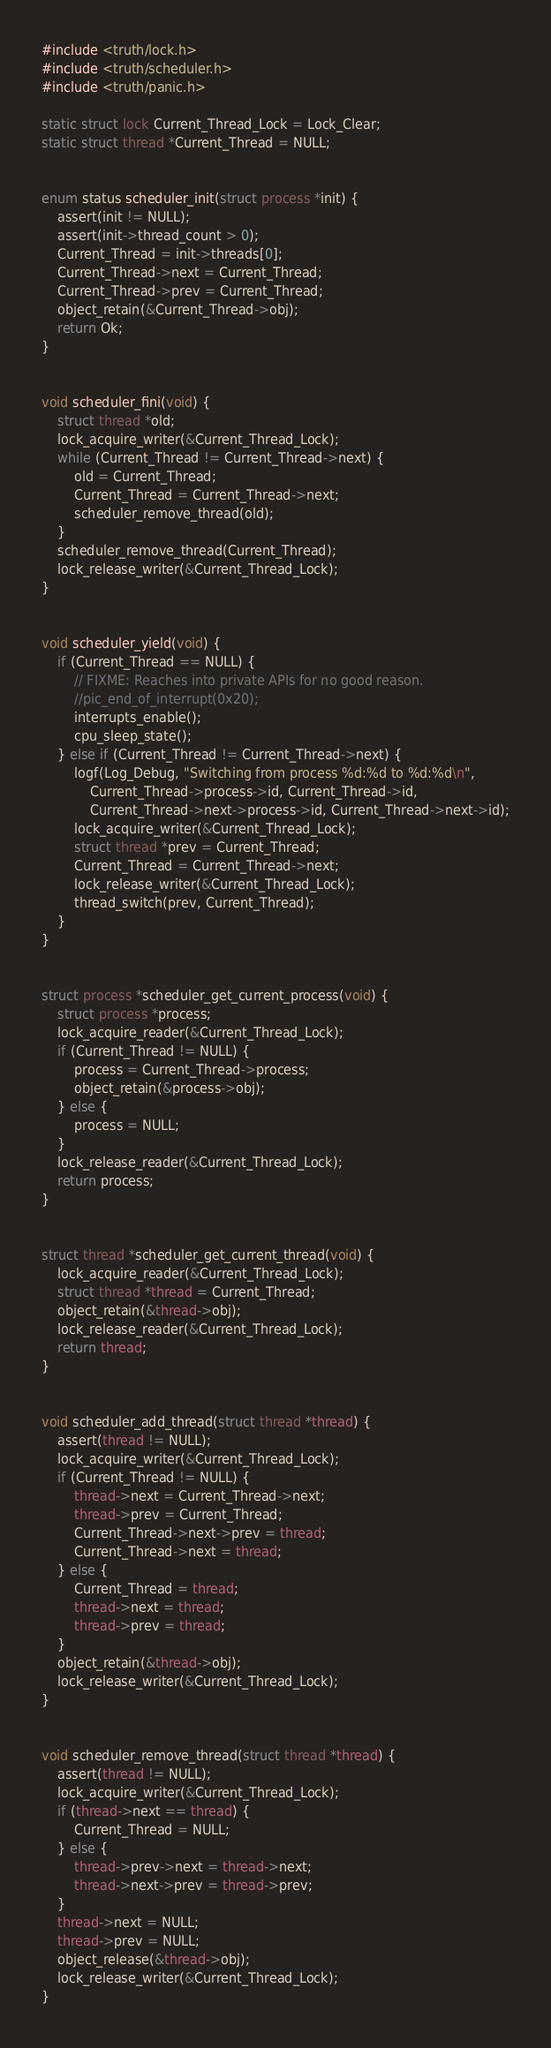Convert code to text. <code><loc_0><loc_0><loc_500><loc_500><_C_>#include <truth/lock.h>
#include <truth/scheduler.h>
#include <truth/panic.h>

static struct lock Current_Thread_Lock = Lock_Clear;
static struct thread *Current_Thread = NULL;


enum status scheduler_init(struct process *init) {
    assert(init != NULL);
    assert(init->thread_count > 0);
    Current_Thread = init->threads[0];
    Current_Thread->next = Current_Thread;
    Current_Thread->prev = Current_Thread;
    object_retain(&Current_Thread->obj);
    return Ok;
}


void scheduler_fini(void) {
    struct thread *old;
    lock_acquire_writer(&Current_Thread_Lock);
    while (Current_Thread != Current_Thread->next) {
        old = Current_Thread;
        Current_Thread = Current_Thread->next;
        scheduler_remove_thread(old);
    }
    scheduler_remove_thread(Current_Thread);
    lock_release_writer(&Current_Thread_Lock);
}


void scheduler_yield(void) {
    if (Current_Thread == NULL) {
        // FIXME: Reaches into private APIs for no good reason.
        //pic_end_of_interrupt(0x20);
        interrupts_enable();
        cpu_sleep_state();
    } else if (Current_Thread != Current_Thread->next) {
        logf(Log_Debug, "Switching from process %d:%d to %d:%d\n",
            Current_Thread->process->id, Current_Thread->id,
            Current_Thread->next->process->id, Current_Thread->next->id);
        lock_acquire_writer(&Current_Thread_Lock);
        struct thread *prev = Current_Thread;
        Current_Thread = Current_Thread->next;
        lock_release_writer(&Current_Thread_Lock);
        thread_switch(prev, Current_Thread);
    }
}


struct process *scheduler_get_current_process(void) {
    struct process *process;
    lock_acquire_reader(&Current_Thread_Lock);
    if (Current_Thread != NULL) {
        process = Current_Thread->process;
        object_retain(&process->obj);
    } else {
        process = NULL;
    }
    lock_release_reader(&Current_Thread_Lock);
    return process;
}


struct thread *scheduler_get_current_thread(void) {
    lock_acquire_reader(&Current_Thread_Lock);
    struct thread *thread = Current_Thread;
    object_retain(&thread->obj);
    lock_release_reader(&Current_Thread_Lock);
    return thread;
}


void scheduler_add_thread(struct thread *thread) {
    assert(thread != NULL);
    lock_acquire_writer(&Current_Thread_Lock);
    if (Current_Thread != NULL) {
        thread->next = Current_Thread->next;
        thread->prev = Current_Thread;
        Current_Thread->next->prev = thread;
        Current_Thread->next = thread;
    } else {
        Current_Thread = thread;
        thread->next = thread;
        thread->prev = thread;
    }
    object_retain(&thread->obj);
    lock_release_writer(&Current_Thread_Lock);
}


void scheduler_remove_thread(struct thread *thread) {
    assert(thread != NULL);
    lock_acquire_writer(&Current_Thread_Lock);
    if (thread->next == thread) {
        Current_Thread = NULL;
    } else {
        thread->prev->next = thread->next;
        thread->next->prev = thread->prev;
    }
    thread->next = NULL;
    thread->prev = NULL;
    object_release(&thread->obj);
    lock_release_writer(&Current_Thread_Lock);
}
</code> 